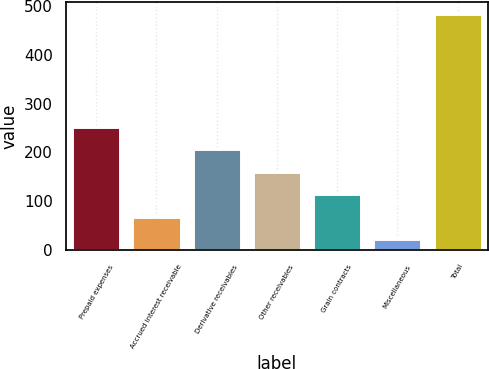Convert chart. <chart><loc_0><loc_0><loc_500><loc_500><bar_chart><fcel>Prepaid expenses<fcel>Accrued interest receivable<fcel>Derivative receivables<fcel>Other receivables<fcel>Grain contracts<fcel>Miscellaneous<fcel>Total<nl><fcel>252.95<fcel>68.51<fcel>206.84<fcel>160.73<fcel>114.62<fcel>22.4<fcel>483.5<nl></chart> 